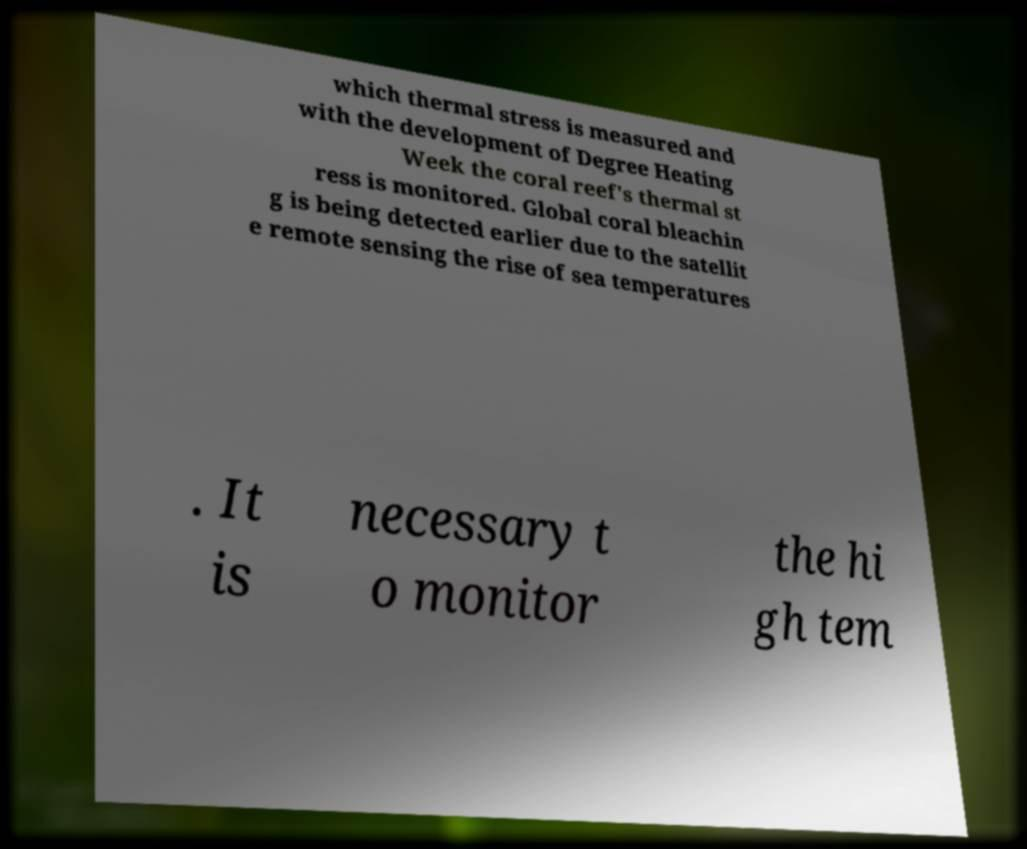I need the written content from this picture converted into text. Can you do that? which thermal stress is measured and with the development of Degree Heating Week the coral reef's thermal st ress is monitored. Global coral bleachin g is being detected earlier due to the satellit e remote sensing the rise of sea temperatures . It is necessary t o monitor the hi gh tem 